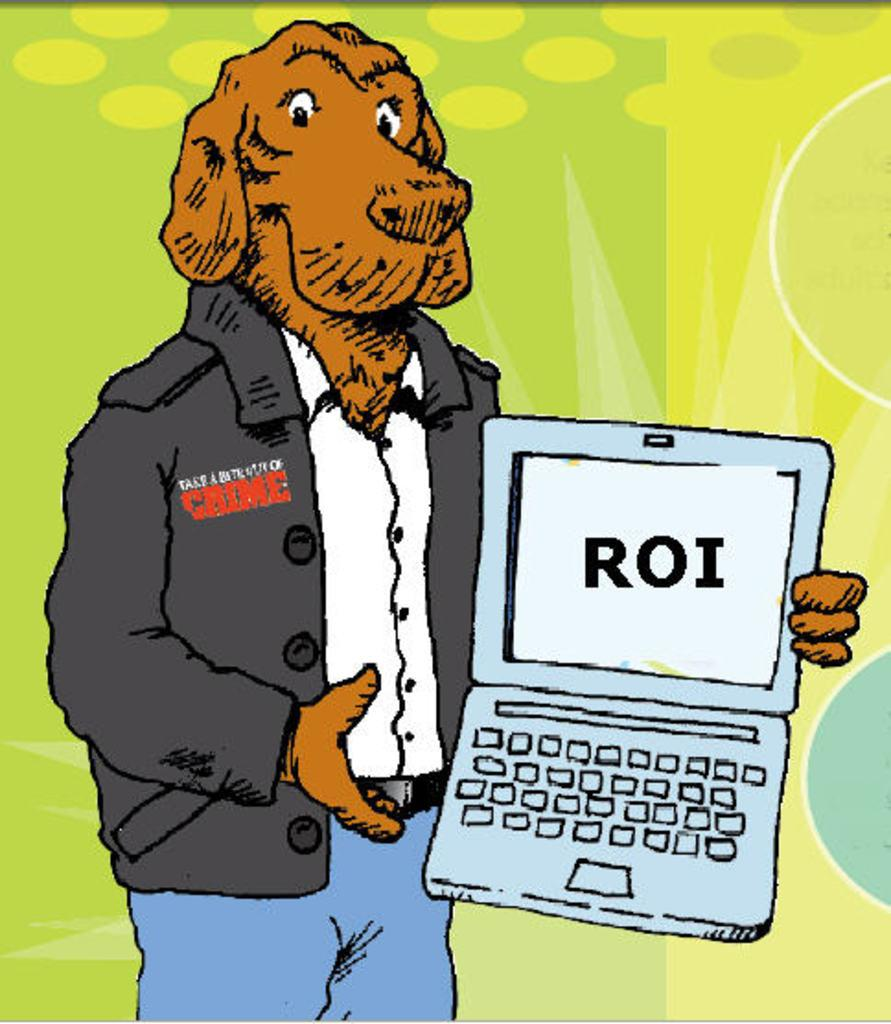What type of artwork is shown in the image? The image is a drawing. What is the main subject of the drawing? The drawing depicts a dog. What clothing items is the dog wearing? The dog is wearing a shirt, a coat, and jeans. What object is the dog holding in the drawing? The dog is holding a laptop. What colors are used in the background of the drawing? The background of the drawing is green and yellow. How many brothers does the dog have in the image? There are no brothers mentioned or depicted in the image, as it features a dog wearing clothes and holding a laptop. What type of key is used to unlock the laptop in the image? There is no key present in the image, as the dog is simply holding the laptop without any indication of it being locked or needing a key to unlock it. 